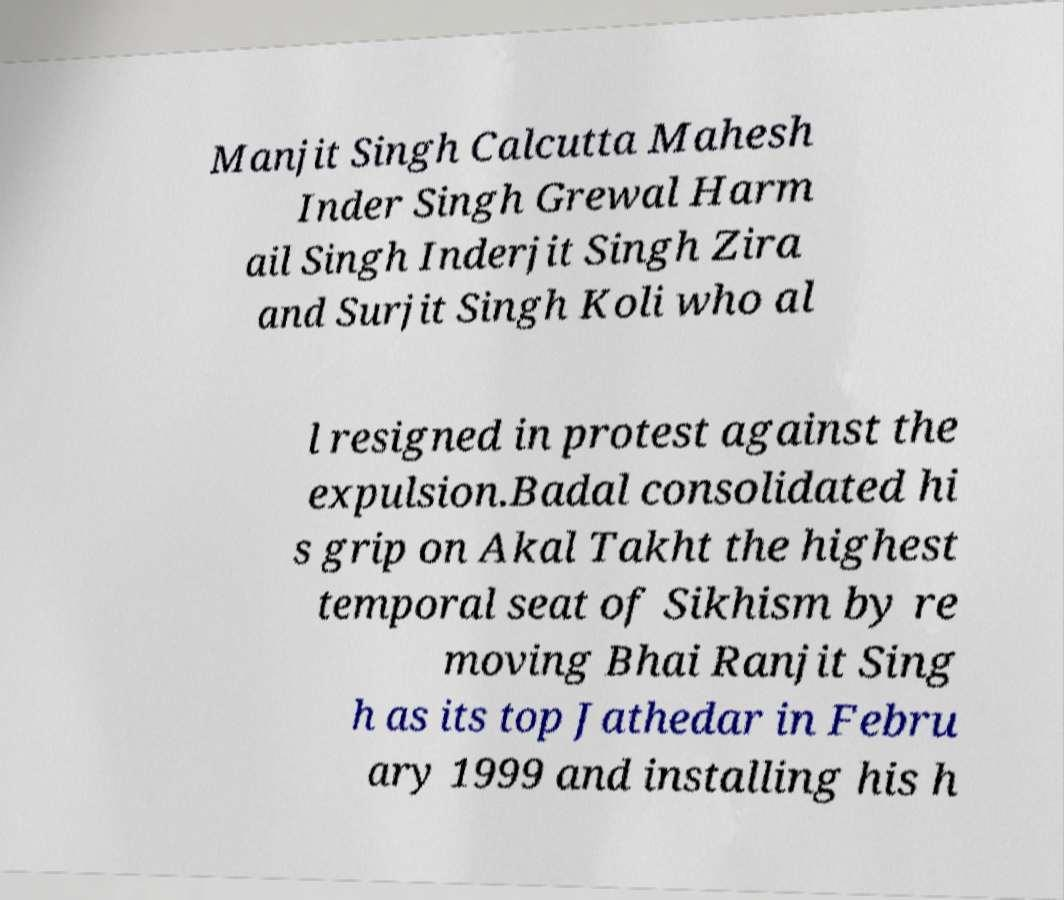Could you extract and type out the text from this image? Manjit Singh Calcutta Mahesh Inder Singh Grewal Harm ail Singh Inderjit Singh Zira and Surjit Singh Koli who al l resigned in protest against the expulsion.Badal consolidated hi s grip on Akal Takht the highest temporal seat of Sikhism by re moving Bhai Ranjit Sing h as its top Jathedar in Febru ary 1999 and installing his h 